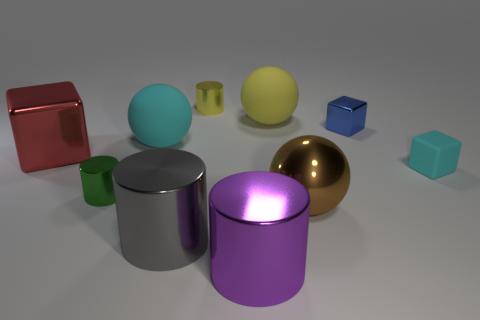Subtract all cylinders. How many objects are left? 6 Add 4 large red shiny objects. How many large red shiny objects are left? 5 Add 5 big matte spheres. How many big matte spheres exist? 7 Subtract 0 yellow cubes. How many objects are left? 10 Subtract all large spheres. Subtract all big metal cylinders. How many objects are left? 5 